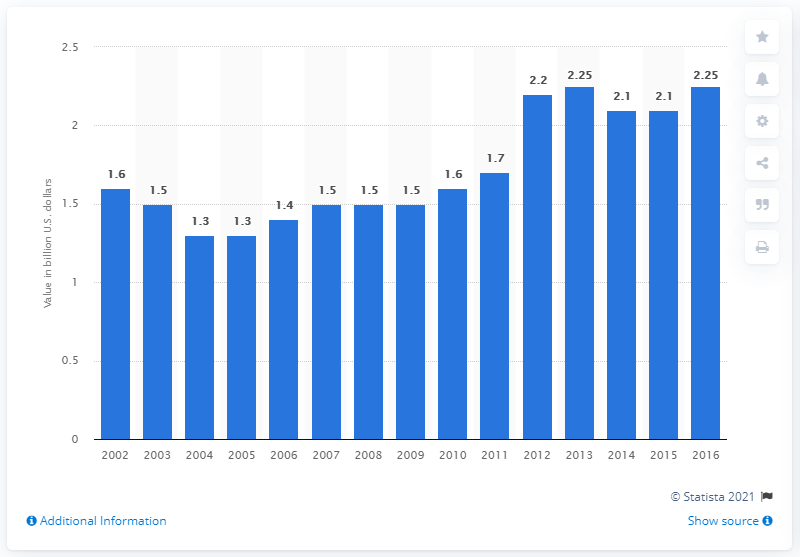Highlight a few significant elements in this photo. In the United States in 2016, the value of product shipments of flavoring powders and tablets was 2.25 billion dollars. 